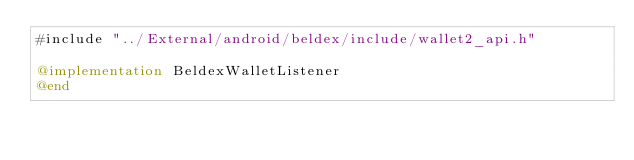Convert code to text. <code><loc_0><loc_0><loc_500><loc_500><_ObjectiveC_>#include "../External/android/beldex/include/wallet2_api.h"

@implementation BeldexWalletListener
@end
</code> 